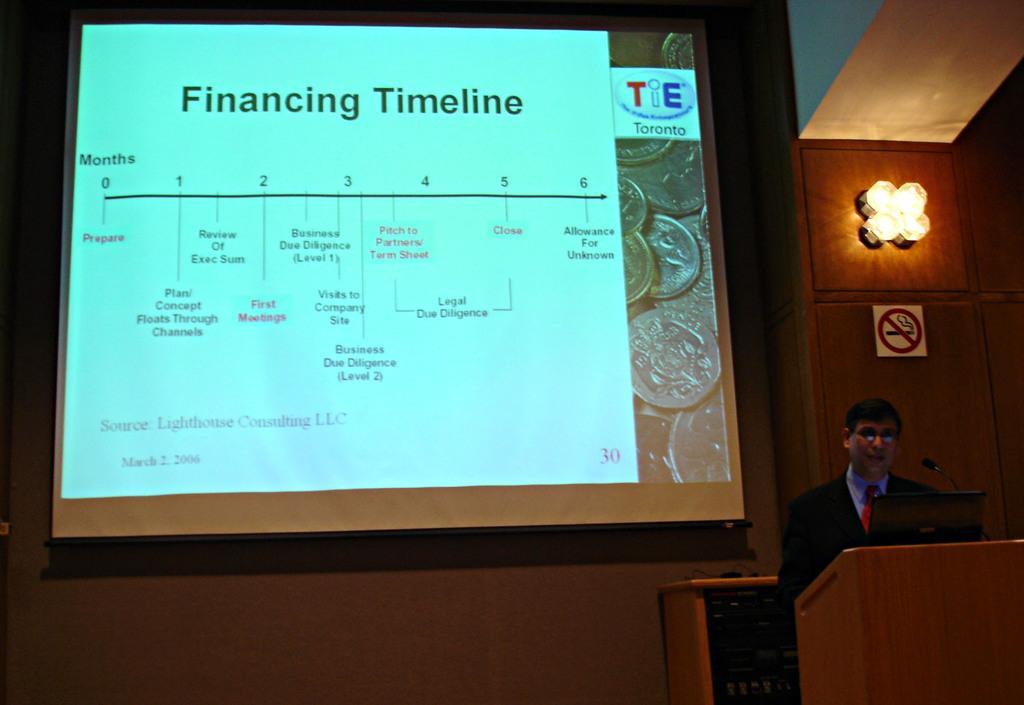How would you summarize this image in a sentence or two? At the top of the image we can see a projector display. At the bottom of the image we can see a cupboard, a person standing near the podium, sign board and a laptop. 